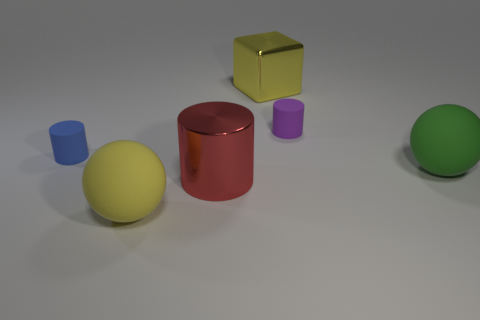Add 3 large yellow metal objects. How many objects exist? 9 Subtract all tiny cylinders. How many cylinders are left? 1 Subtract all blocks. How many objects are left? 5 Subtract 1 balls. How many balls are left? 1 Subtract all green blocks. How many red spheres are left? 0 Subtract all blue metallic balls. Subtract all tiny rubber cylinders. How many objects are left? 4 Add 5 big shiny cylinders. How many big shiny cylinders are left? 6 Add 2 yellow rubber balls. How many yellow rubber balls exist? 3 Subtract all blue cylinders. How many cylinders are left? 2 Subtract 1 purple cylinders. How many objects are left? 5 